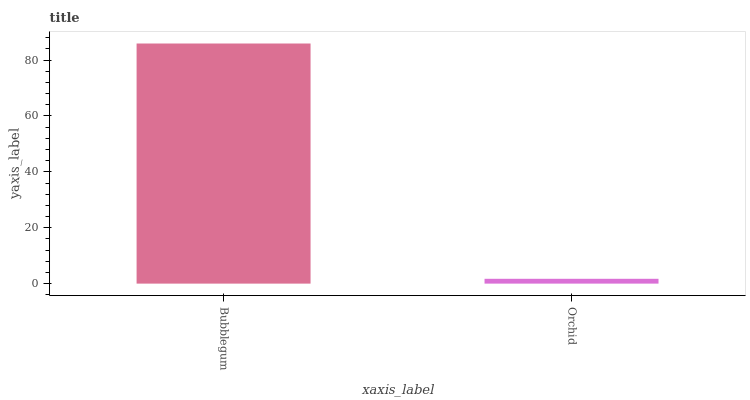Is Orchid the minimum?
Answer yes or no. Yes. Is Bubblegum the maximum?
Answer yes or no. Yes. Is Orchid the maximum?
Answer yes or no. No. Is Bubblegum greater than Orchid?
Answer yes or no. Yes. Is Orchid less than Bubblegum?
Answer yes or no. Yes. Is Orchid greater than Bubblegum?
Answer yes or no. No. Is Bubblegum less than Orchid?
Answer yes or no. No. Is Bubblegum the high median?
Answer yes or no. Yes. Is Orchid the low median?
Answer yes or no. Yes. Is Orchid the high median?
Answer yes or no. No. Is Bubblegum the low median?
Answer yes or no. No. 